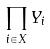<formula> <loc_0><loc_0><loc_500><loc_500>\prod _ { i \in X } Y _ { i }</formula> 